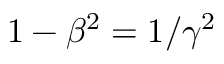<formula> <loc_0><loc_0><loc_500><loc_500>1 - \beta ^ { 2 } = 1 / \gamma ^ { 2 }</formula> 